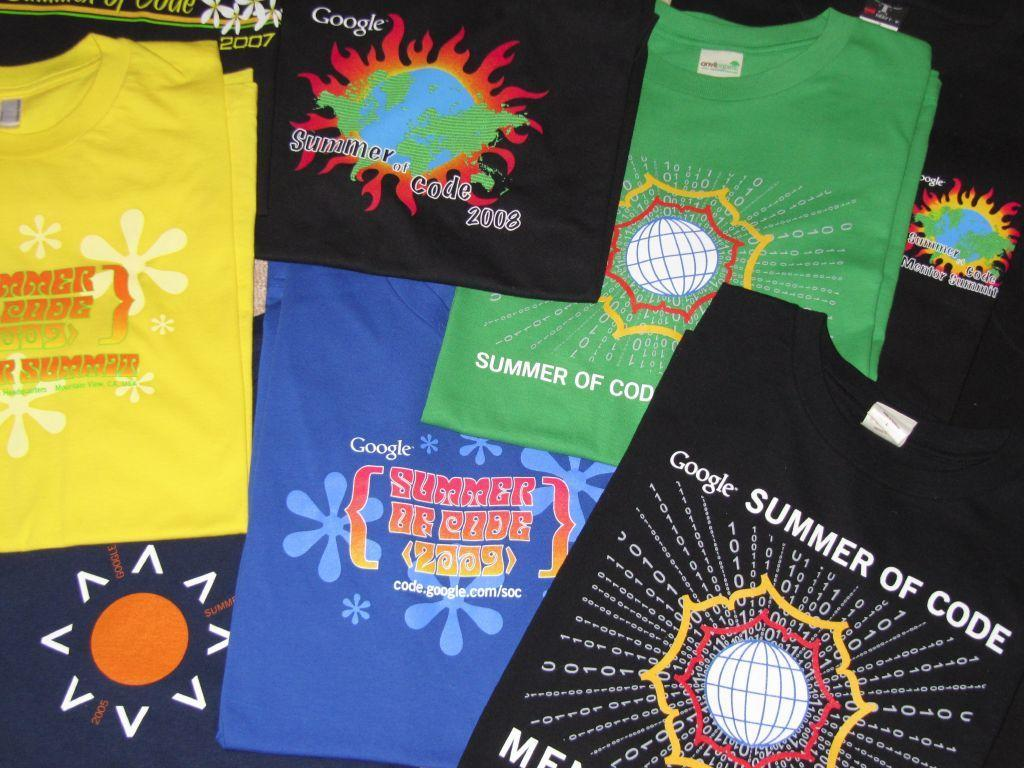What type of clothing items are present in the image? There are many colorful folded T-shirts in the image. What can be observed about the appearance of the T-shirts? The T-shirts have a design on them. Is there any text present on the T-shirts? Yes, there is text on the T-shirts. How many pigs are visible on the T-shirts in the image? There are no pigs visible on the T-shirts in the image. What type of agreement is being made between the T-shirts in the image? There is no agreement being made between the T-shirts in the image, as they are folded and inanimate objects. 